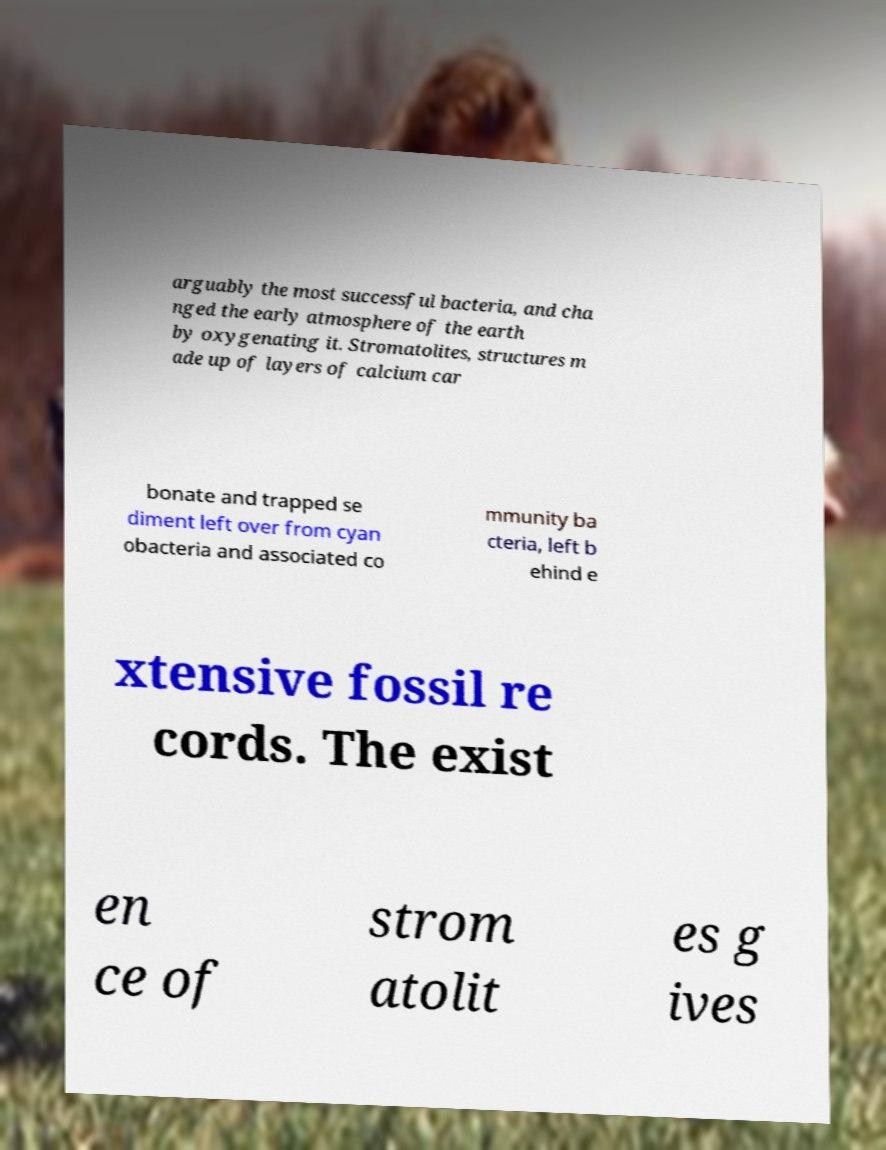Please identify and transcribe the text found in this image. arguably the most successful bacteria, and cha nged the early atmosphere of the earth by oxygenating it. Stromatolites, structures m ade up of layers of calcium car bonate and trapped se diment left over from cyan obacteria and associated co mmunity ba cteria, left b ehind e xtensive fossil re cords. The exist en ce of strom atolit es g ives 